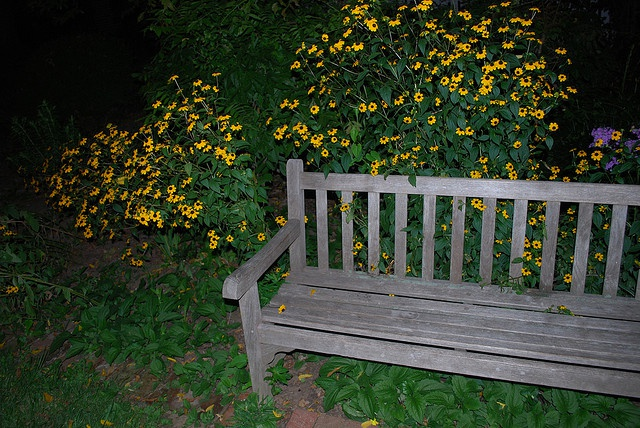Describe the objects in this image and their specific colors. I can see a bench in black, gray, and darkgreen tones in this image. 